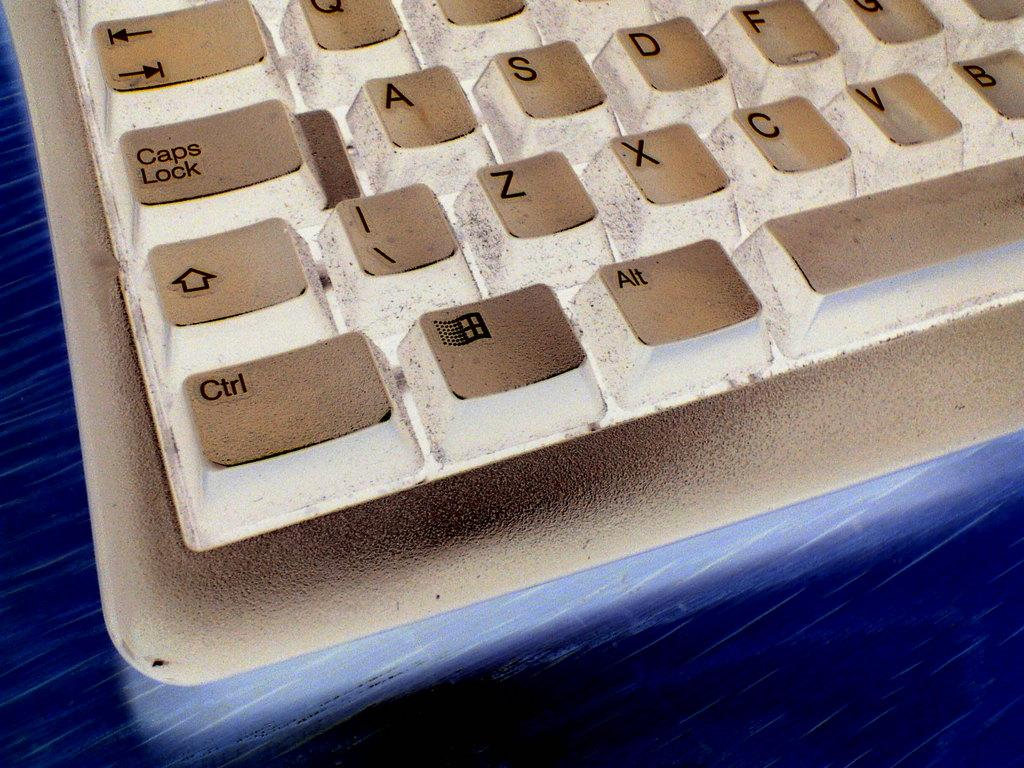What is the main object in the image? There is a keyboard in the image. What color is the keyboard? The keyboard is white in color. What is the opinion of the sun about the keyboard in the image? The sun does not have an opinion, as it is a celestial body and cannot express opinions. 